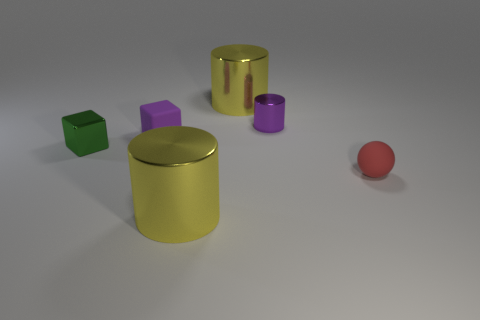How many other things are there of the same color as the small metallic cylinder?
Ensure brevity in your answer.  1. The object that is both left of the tiny rubber ball and in front of the green thing is what color?
Ensure brevity in your answer.  Yellow. How many small matte spheres are there?
Provide a short and direct response. 1. Is the tiny green object made of the same material as the red object?
Give a very brief answer. No. There is a yellow thing behind the metallic thing left of the cube that is to the right of the green shiny block; what shape is it?
Offer a terse response. Cylinder. Is the material of the big thing behind the purple cylinder the same as the large yellow object that is in front of the small purple cylinder?
Give a very brief answer. Yes. What is the ball made of?
Your answer should be compact. Rubber. What number of small shiny objects are the same shape as the purple rubber object?
Your response must be concise. 1. There is a small cylinder that is the same color as the matte block; what material is it?
Your answer should be compact. Metal. Is there anything else that is the same shape as the red thing?
Give a very brief answer. No. 